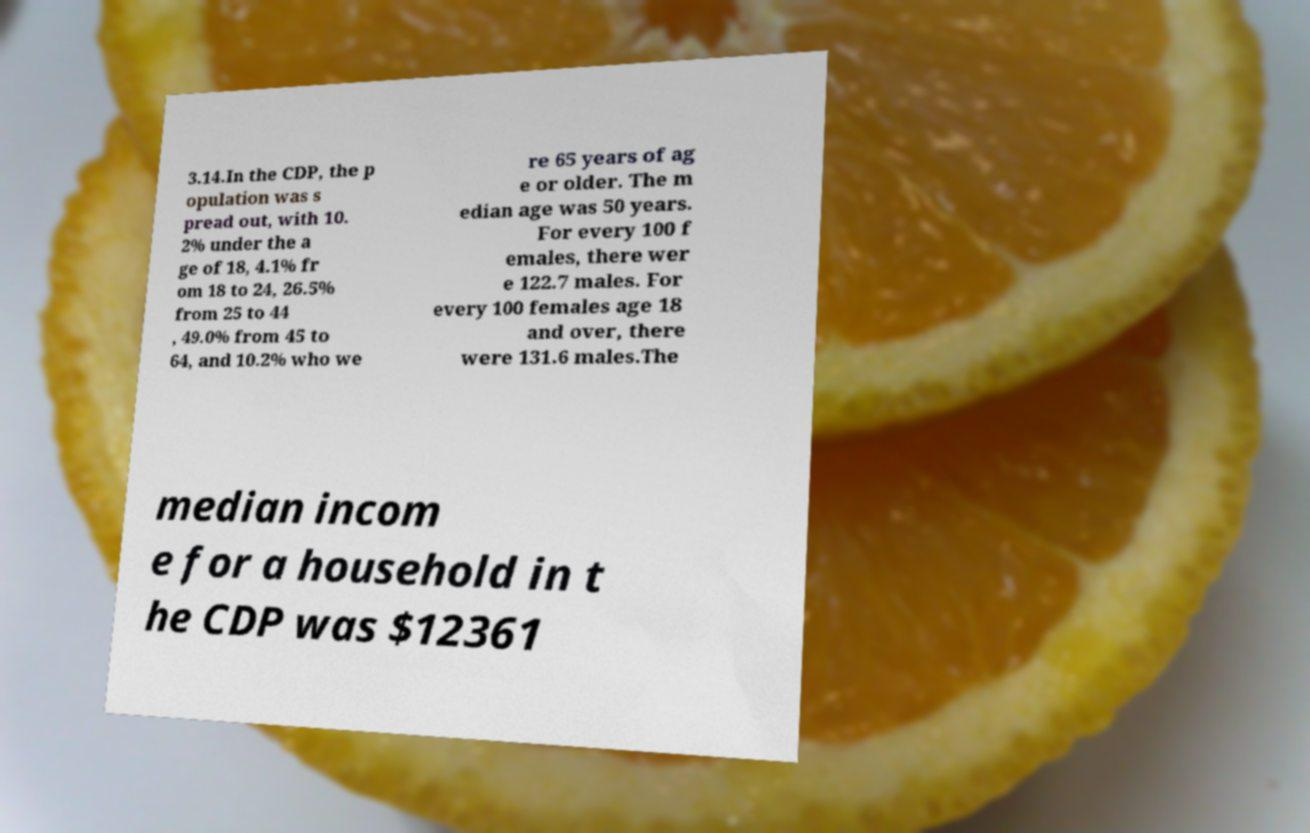I need the written content from this picture converted into text. Can you do that? 3.14.In the CDP, the p opulation was s pread out, with 10. 2% under the a ge of 18, 4.1% fr om 18 to 24, 26.5% from 25 to 44 , 49.0% from 45 to 64, and 10.2% who we re 65 years of ag e or older. The m edian age was 50 years. For every 100 f emales, there wer e 122.7 males. For every 100 females age 18 and over, there were 131.6 males.The median incom e for a household in t he CDP was $12361 